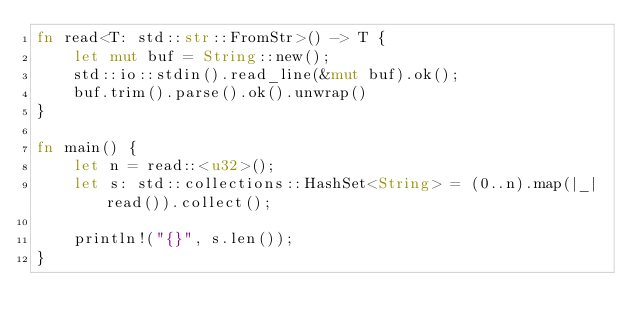Convert code to text. <code><loc_0><loc_0><loc_500><loc_500><_Rust_>fn read<T: std::str::FromStr>() -> T {
    let mut buf = String::new();
    std::io::stdin().read_line(&mut buf).ok();
    buf.trim().parse().ok().unwrap()
}

fn main() {
    let n = read::<u32>();
    let s: std::collections::HashSet<String> = (0..n).map(|_| read()).collect();

    println!("{}", s.len());
}
</code> 